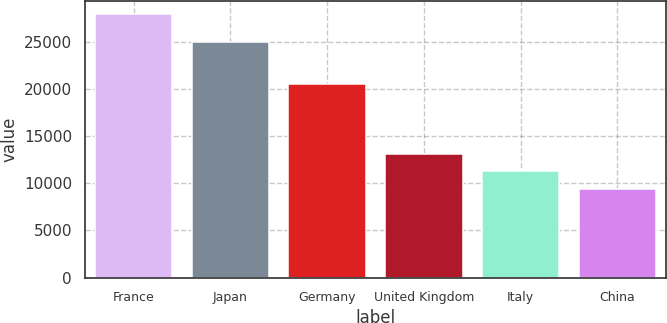<chart> <loc_0><loc_0><loc_500><loc_500><bar_chart><fcel>France<fcel>Japan<fcel>Germany<fcel>United Kingdom<fcel>Italy<fcel>China<nl><fcel>27923<fcel>24998<fcel>20470<fcel>13112.6<fcel>11261.3<fcel>9410<nl></chart> 